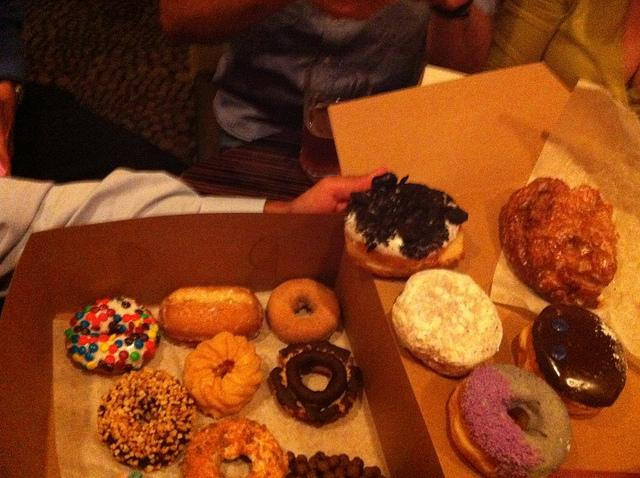What unhealthy ingredient does this food contain the most? Please explain your reasoning. sugar. The donuts have sugar. 